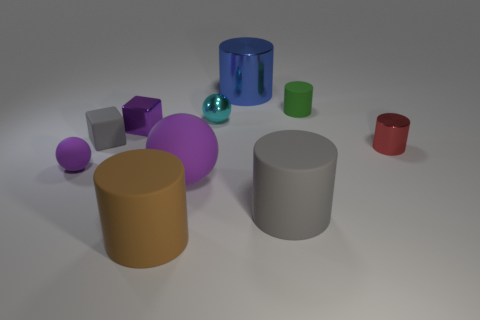Does the brown matte object have the same shape as the small metallic object that is on the right side of the green thing?
Give a very brief answer. Yes. Do the ball behind the red cylinder and the shiny object on the right side of the large blue metal cylinder have the same size?
Your answer should be compact. Yes. What number of other things are the same shape as the cyan thing?
Keep it short and to the point. 2. The gray thing that is behind the metal cylinder in front of the cyan sphere is made of what material?
Ensure brevity in your answer.  Rubber. How many rubber things are tiny red things or small red spheres?
Offer a terse response. 0. Is there anything else that is the same material as the small cyan object?
Keep it short and to the point. Yes. Is there a block behind the tiny sphere behind the purple metallic cube?
Provide a succinct answer. No. What number of objects are either purple spheres that are to the right of the tiny purple shiny cube or cyan metal things that are behind the small metal cube?
Provide a succinct answer. 2. Is there anything else of the same color as the small shiny cylinder?
Offer a very short reply. No. What is the color of the large object that is behind the matte thing that is behind the gray matte object that is on the left side of the blue metal cylinder?
Offer a terse response. Blue. 